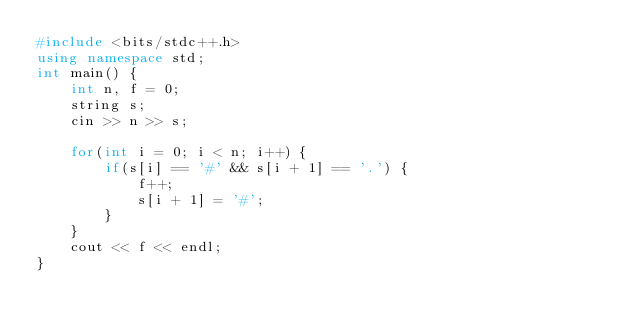Convert code to text. <code><loc_0><loc_0><loc_500><loc_500><_C++_>#include <bits/stdc++.h>
using namespace std;
int main() {
    int n, f = 0;
    string s;
    cin >> n >> s;

    for(int i = 0; i < n; i++) {
        if(s[i] == '#' && s[i + 1] == '.') {
            f++;
            s[i + 1] = '#';
        }
    }
    cout << f << endl;
}</code> 